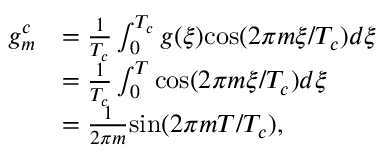<formula> <loc_0><loc_0><loc_500><loc_500>\begin{array} { r l } { g _ { m } ^ { c } } & { = \frac { 1 } { T _ { c } } \int _ { 0 } ^ { T _ { c } } g ( \xi ) \cos ( 2 \pi m \xi / T _ { c } ) d \xi } \\ & { = \frac { 1 } { T _ { c } } \int _ { 0 } ^ { T } \cos ( 2 \pi m \xi / T _ { c } ) d \xi } \\ & { = \frac { 1 } { 2 \pi m } \sin ( 2 \pi m T / T _ { c } ) , } \end{array}</formula> 